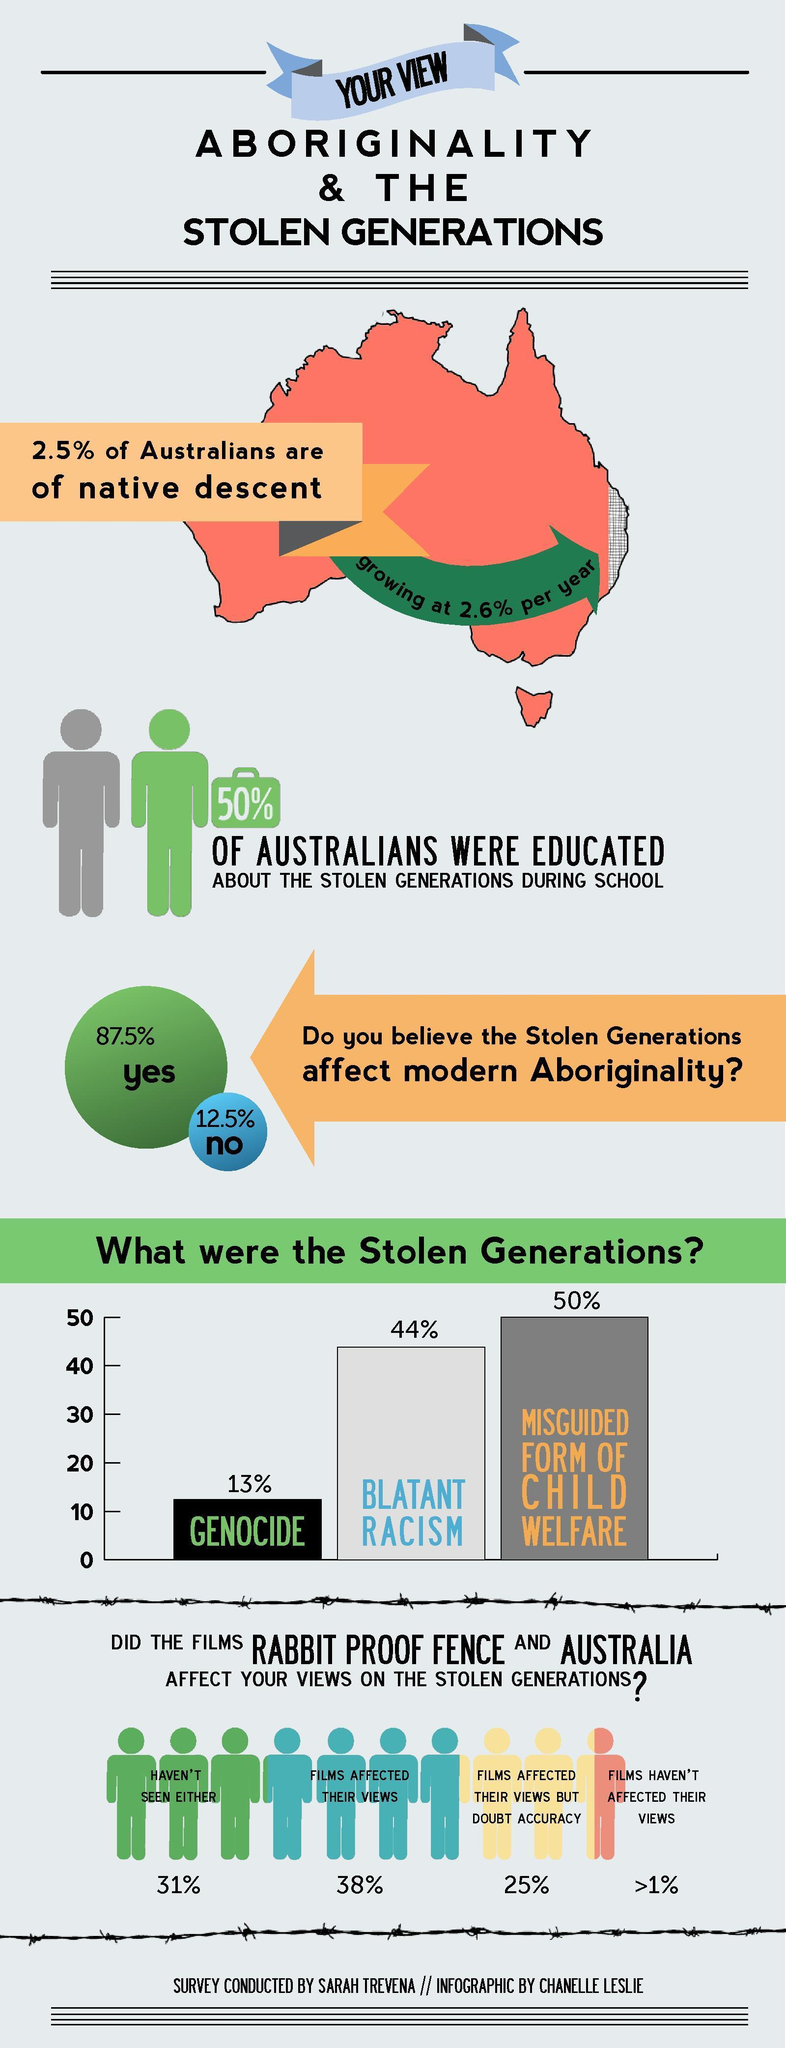Which was the top most reason for Stolen Generations?
Answer the question with a short phrase. MISGUIDED FORM OF CHILD WELFARE What percent of people were affected by the films? 38% 